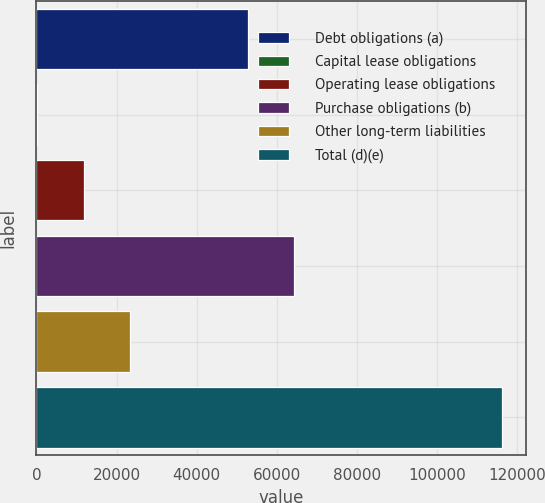Convert chart to OTSL. <chart><loc_0><loc_0><loc_500><loc_500><bar_chart><fcel>Debt obligations (a)<fcel>Capital lease obligations<fcel>Operating lease obligations<fcel>Purchase obligations (b)<fcel>Other long-term liabilities<fcel>Total (d)(e)<nl><fcel>52727<fcel>156<fcel>11767<fcel>64338<fcel>23378<fcel>116266<nl></chart> 